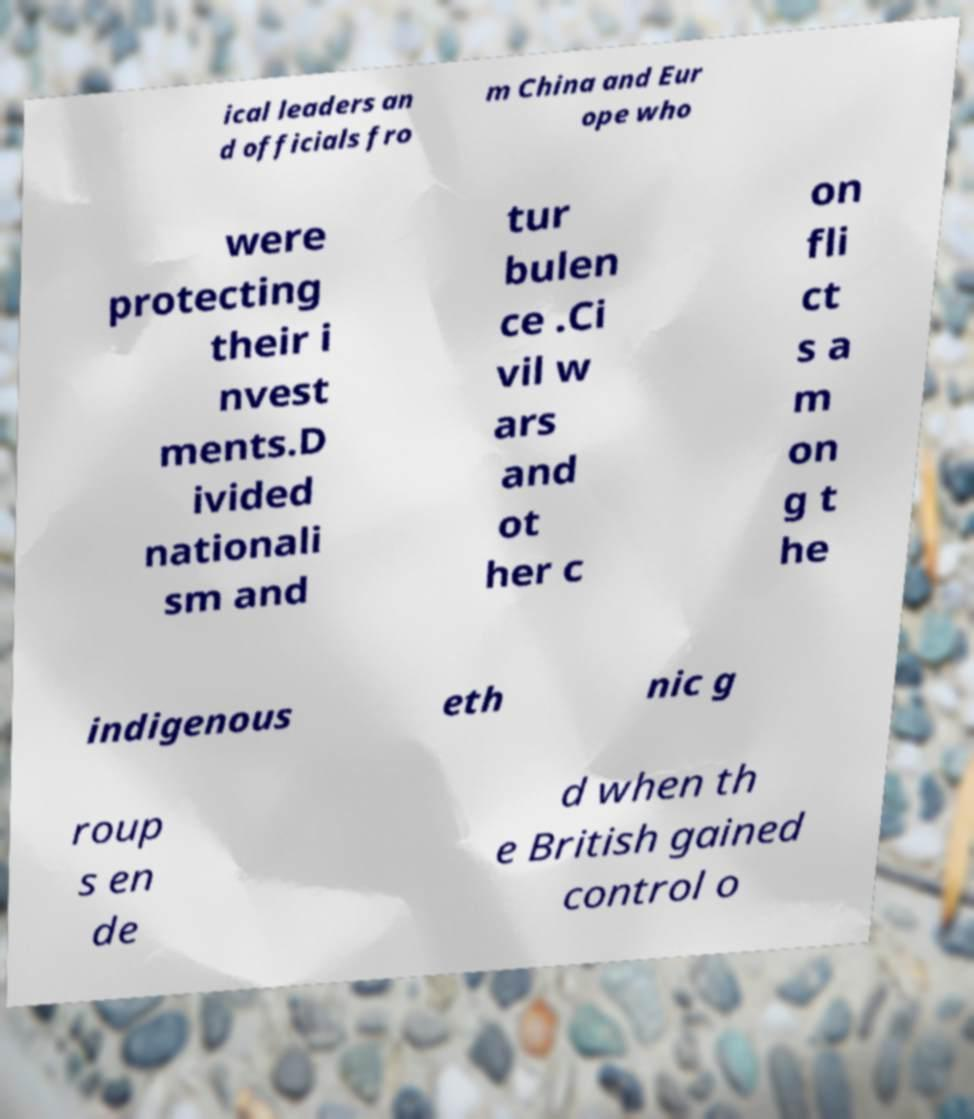Please identify and transcribe the text found in this image. ical leaders an d officials fro m China and Eur ope who were protecting their i nvest ments.D ivided nationali sm and tur bulen ce .Ci vil w ars and ot her c on fli ct s a m on g t he indigenous eth nic g roup s en de d when th e British gained control o 